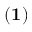Convert formula to latex. <formula><loc_0><loc_0><loc_500><loc_500>{ ( 1 ) }</formula> 